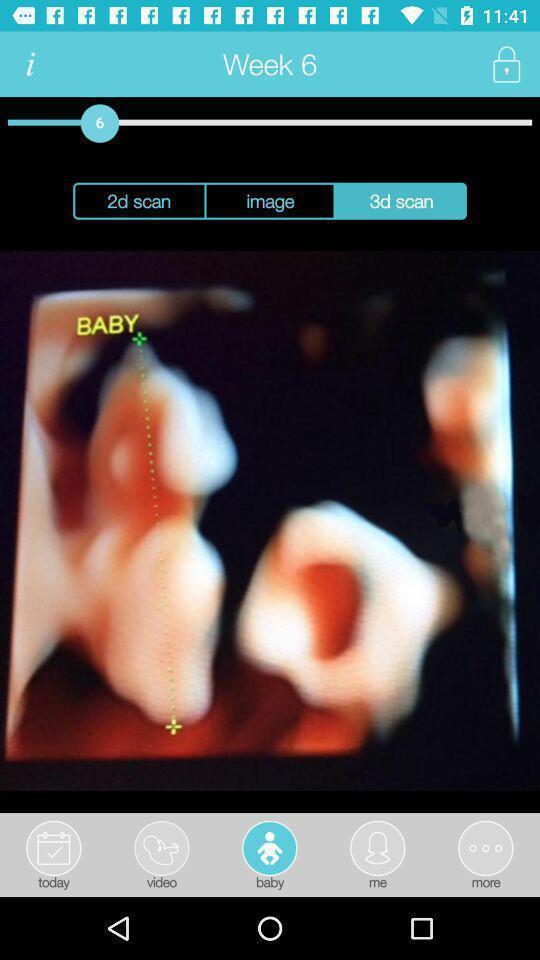Explain the elements present in this screenshot. Screen shows a pregnancy app. 